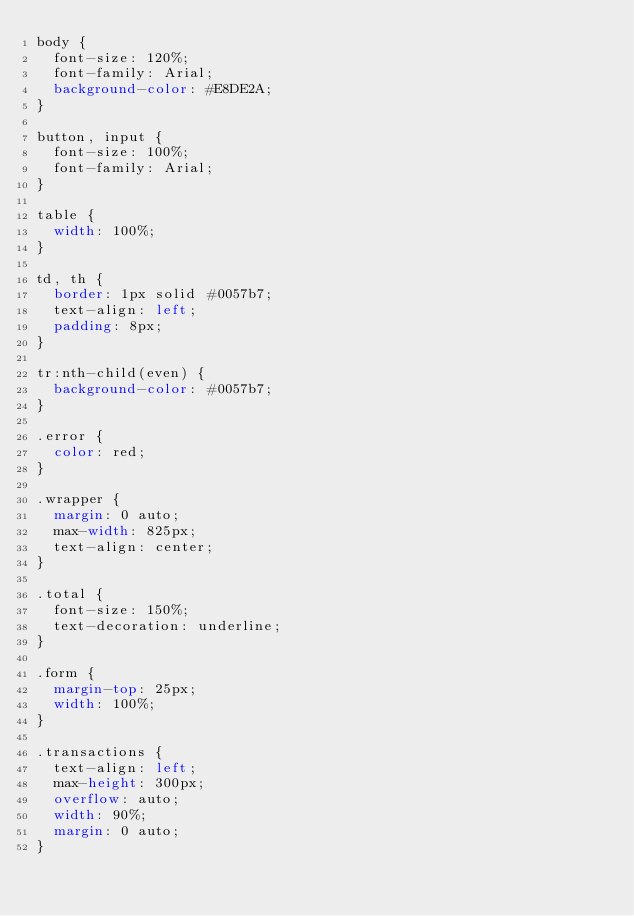<code> <loc_0><loc_0><loc_500><loc_500><_CSS_>body {
  font-size: 120%;
  font-family: Arial;
  background-color: #E8DE2A;
}

button, input {
  font-size: 100%;
  font-family: Arial;
}

table {
  width: 100%;
}

td, th {
  border: 1px solid #0057b7;
  text-align: left;
  padding: 8px;
}

tr:nth-child(even) {
  background-color: #0057b7;
}

.error {
  color: red;
}

.wrapper {
  margin: 0 auto;
  max-width: 825px;
  text-align: center;
}

.total {
  font-size: 150%;
  text-decoration: underline;
}

.form {
  margin-top: 25px;
  width: 100%;
}

.transactions {
  text-align: left;
  max-height: 300px;
  overflow: auto;
  width: 90%;
  margin: 0 auto;
}
</code> 